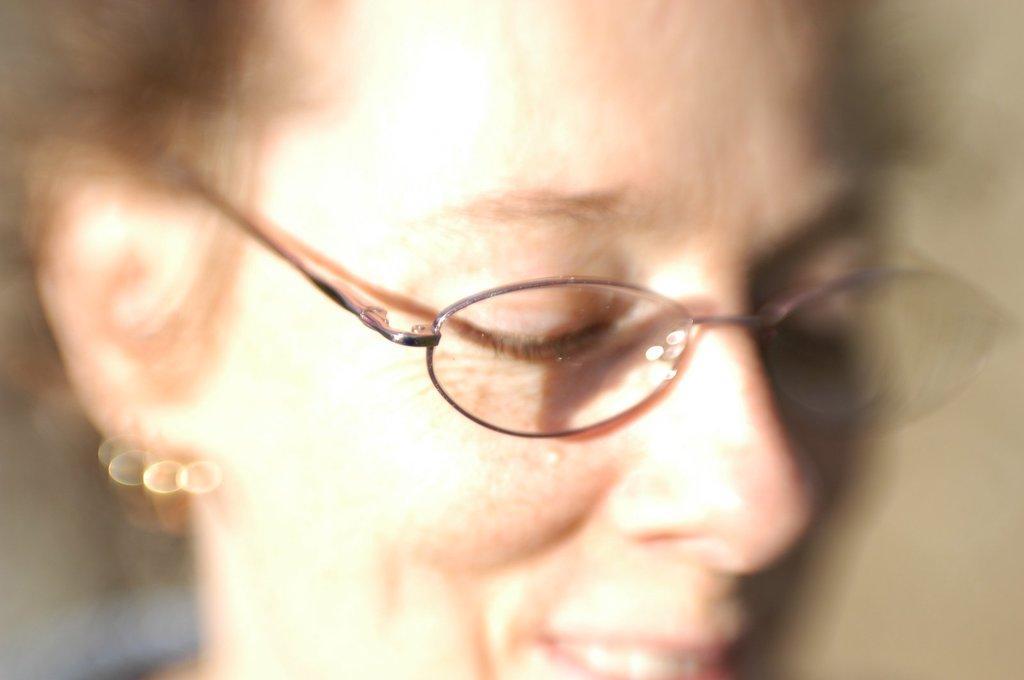Can you describe this image briefly? This picture is blur, we can see person face wore spectacle. 